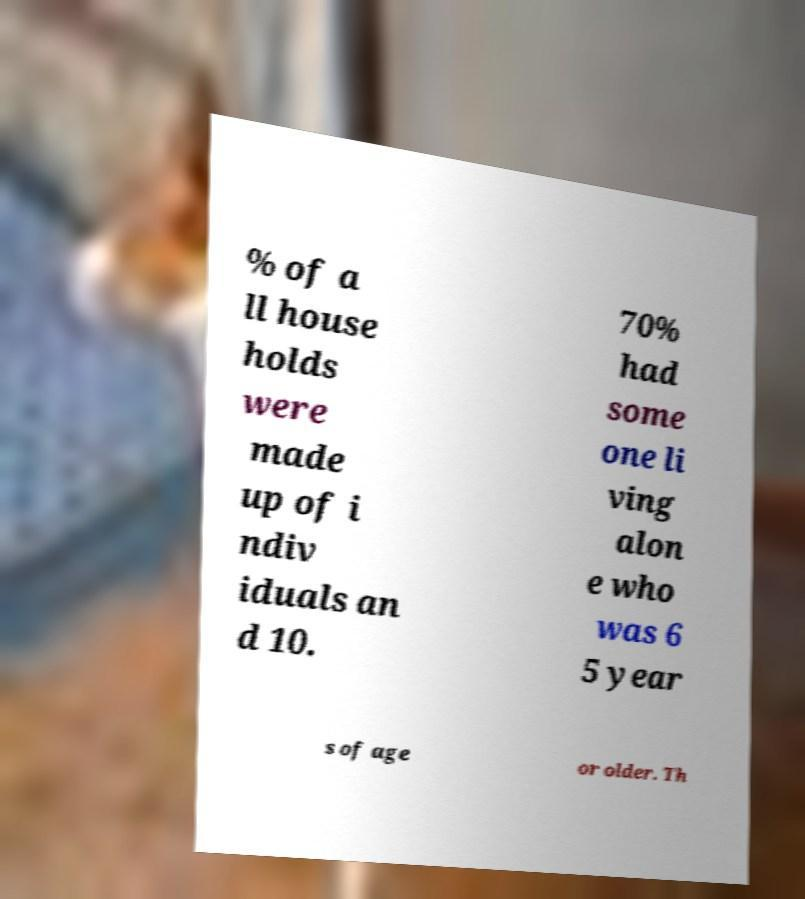Can you accurately transcribe the text from the provided image for me? % of a ll house holds were made up of i ndiv iduals an d 10. 70% had some one li ving alon e who was 6 5 year s of age or older. Th 